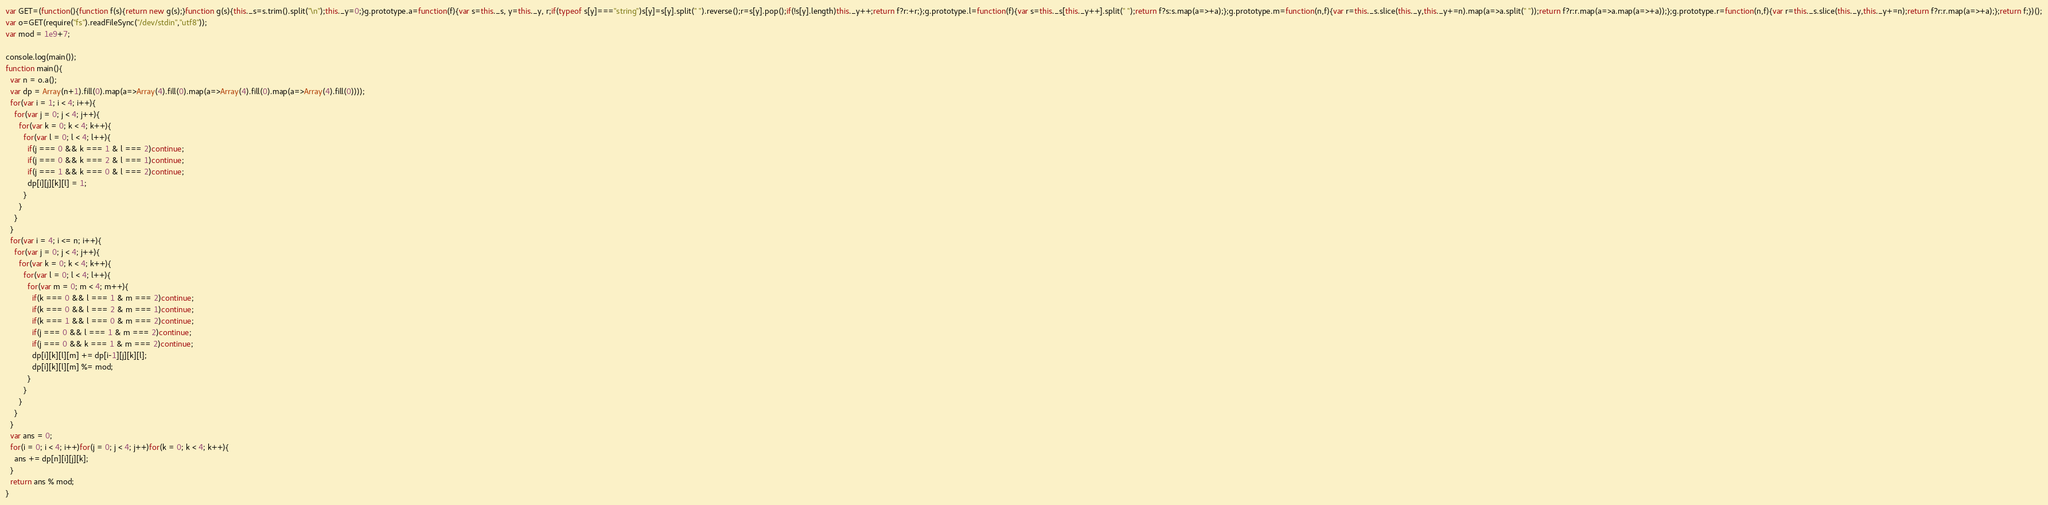<code> <loc_0><loc_0><loc_500><loc_500><_JavaScript_>var GET=(function(){function f(s){return new g(s);}function g(s){this._s=s.trim().split("\n");this._y=0;}g.prototype.a=function(f){var s=this._s, y=this._y, r;if(typeof s[y]==="string")s[y]=s[y].split(" ").reverse();r=s[y].pop();if(!s[y].length)this._y++;return f?r:+r;};g.prototype.l=function(f){var s=this._s[this._y++].split(" ");return f?s:s.map(a=>+a);};g.prototype.m=function(n,f){var r=this._s.slice(this._y,this._y+=n).map(a=>a.split(" "));return f?r:r.map(a=>a.map(a=>+a));};g.prototype.r=function(n,f){var r=this._s.slice(this._y,this._y+=n);return f?r:r.map(a=>+a);};return f;})();
var o=GET(require("fs").readFileSync("/dev/stdin","utf8"));
var mod = 1e9+7;

console.log(main());
function main(){
  var n = o.a();
  var dp = Array(n+1).fill(0).map(a=>Array(4).fill(0).map(a=>Array(4).fill(0).map(a=>Array(4).fill(0))));
  for(var i = 1; i < 4; i++){
    for(var j = 0; j < 4; j++){
      for(var k = 0; k < 4; k++){
        for(var l = 0; l < 4; l++){
          if(j === 0 && k === 1 & l === 2)continue;
          if(j === 0 && k === 2 & l === 1)continue;
          if(j === 1 && k === 0 & l === 2)continue;
          dp[i][j][k][l] = 1;
        }
      }
    }
  }
  for(var i = 4; i <= n; i++){
    for(var j = 0; j < 4; j++){
      for(var k = 0; k < 4; k++){
        for(var l = 0; l < 4; l++){
          for(var m = 0; m < 4; m++){
            if(k === 0 && l === 1 & m === 2)continue;
            if(k === 0 && l === 2 & m === 1)continue;
            if(k === 1 && l === 0 & m === 2)continue;
            if(j === 0 && l === 1 & m === 2)continue;
            if(j === 0 && k === 1 & m === 2)continue;
            dp[i][k][l][m] += dp[i-1][j][k][l];
            dp[i][k][l][m] %= mod;
          }
        }
      }
    }
  }
  var ans = 0;
  for(i = 0; i < 4; i++)for(j = 0; j < 4; j++)for(k = 0; k < 4; k++){
    ans += dp[n][i][j][k];
  }
  return ans % mod;
}</code> 